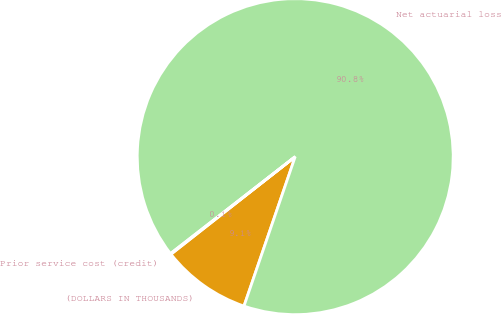Convert chart. <chart><loc_0><loc_0><loc_500><loc_500><pie_chart><fcel>(DOLLARS IN THOUSANDS)<fcel>Net actuarial loss<fcel>Prior service cost (credit)<nl><fcel>9.15%<fcel>90.77%<fcel>0.08%<nl></chart> 